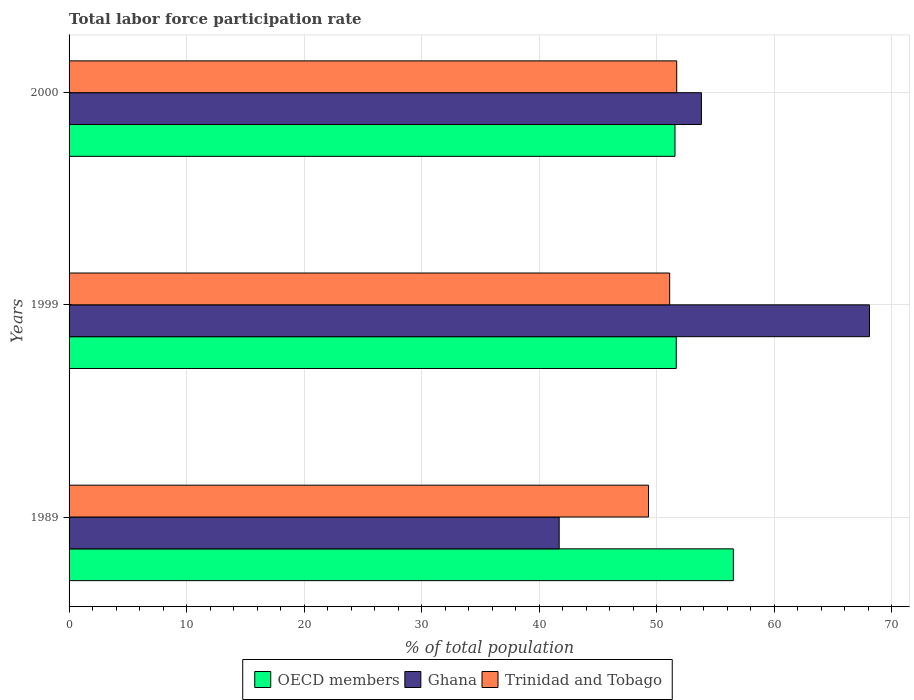How many different coloured bars are there?
Provide a succinct answer. 3. How many groups of bars are there?
Keep it short and to the point. 3. Are the number of bars on each tick of the Y-axis equal?
Offer a very short reply. Yes. How many bars are there on the 1st tick from the bottom?
Keep it short and to the point. 3. What is the total labor force participation rate in Trinidad and Tobago in 1999?
Offer a very short reply. 51.1. Across all years, what is the maximum total labor force participation rate in OECD members?
Offer a very short reply. 56.52. Across all years, what is the minimum total labor force participation rate in Trinidad and Tobago?
Your answer should be compact. 49.3. What is the total total labor force participation rate in Trinidad and Tobago in the graph?
Give a very brief answer. 152.1. What is the difference between the total labor force participation rate in Ghana in 1999 and that in 2000?
Make the answer very short. 14.3. What is the difference between the total labor force participation rate in OECD members in 1989 and the total labor force participation rate in Ghana in 1999?
Provide a short and direct response. -11.58. What is the average total labor force participation rate in Ghana per year?
Your answer should be compact. 54.53. In the year 1989, what is the difference between the total labor force participation rate in Ghana and total labor force participation rate in OECD members?
Your response must be concise. -14.82. What is the ratio of the total labor force participation rate in Trinidad and Tobago in 1989 to that in 2000?
Your answer should be very brief. 0.95. What is the difference between the highest and the second highest total labor force participation rate in Ghana?
Your answer should be compact. 14.3. What is the difference between the highest and the lowest total labor force participation rate in Trinidad and Tobago?
Your response must be concise. 2.4. In how many years, is the total labor force participation rate in Ghana greater than the average total labor force participation rate in Ghana taken over all years?
Offer a very short reply. 1. Is the sum of the total labor force participation rate in OECD members in 1989 and 2000 greater than the maximum total labor force participation rate in Trinidad and Tobago across all years?
Keep it short and to the point. Yes. How many bars are there?
Keep it short and to the point. 9. Are all the bars in the graph horizontal?
Give a very brief answer. Yes. How many legend labels are there?
Make the answer very short. 3. How are the legend labels stacked?
Keep it short and to the point. Horizontal. What is the title of the graph?
Make the answer very short. Total labor force participation rate. What is the label or title of the X-axis?
Give a very brief answer. % of total population. What is the % of total population of OECD members in 1989?
Provide a succinct answer. 56.52. What is the % of total population in Ghana in 1989?
Keep it short and to the point. 41.7. What is the % of total population of Trinidad and Tobago in 1989?
Keep it short and to the point. 49.3. What is the % of total population in OECD members in 1999?
Offer a very short reply. 51.66. What is the % of total population of Ghana in 1999?
Offer a very short reply. 68.1. What is the % of total population of Trinidad and Tobago in 1999?
Make the answer very short. 51.1. What is the % of total population of OECD members in 2000?
Make the answer very short. 51.55. What is the % of total population in Ghana in 2000?
Make the answer very short. 53.8. What is the % of total population in Trinidad and Tobago in 2000?
Offer a terse response. 51.7. Across all years, what is the maximum % of total population of OECD members?
Your answer should be compact. 56.52. Across all years, what is the maximum % of total population in Ghana?
Give a very brief answer. 68.1. Across all years, what is the maximum % of total population in Trinidad and Tobago?
Your response must be concise. 51.7. Across all years, what is the minimum % of total population of OECD members?
Your response must be concise. 51.55. Across all years, what is the minimum % of total population of Ghana?
Offer a very short reply. 41.7. Across all years, what is the minimum % of total population of Trinidad and Tobago?
Offer a very short reply. 49.3. What is the total % of total population of OECD members in the graph?
Offer a terse response. 159.73. What is the total % of total population in Ghana in the graph?
Give a very brief answer. 163.6. What is the total % of total population in Trinidad and Tobago in the graph?
Your response must be concise. 152.1. What is the difference between the % of total population in OECD members in 1989 and that in 1999?
Give a very brief answer. 4.86. What is the difference between the % of total population of Ghana in 1989 and that in 1999?
Offer a terse response. -26.4. What is the difference between the % of total population of Trinidad and Tobago in 1989 and that in 1999?
Your answer should be very brief. -1.8. What is the difference between the % of total population in OECD members in 1989 and that in 2000?
Your answer should be compact. 4.96. What is the difference between the % of total population in OECD members in 1999 and that in 2000?
Ensure brevity in your answer.  0.11. What is the difference between the % of total population in Ghana in 1999 and that in 2000?
Make the answer very short. 14.3. What is the difference between the % of total population in Trinidad and Tobago in 1999 and that in 2000?
Make the answer very short. -0.6. What is the difference between the % of total population in OECD members in 1989 and the % of total population in Ghana in 1999?
Your answer should be compact. -11.58. What is the difference between the % of total population of OECD members in 1989 and the % of total population of Trinidad and Tobago in 1999?
Your response must be concise. 5.42. What is the difference between the % of total population of Ghana in 1989 and the % of total population of Trinidad and Tobago in 1999?
Offer a terse response. -9.4. What is the difference between the % of total population in OECD members in 1989 and the % of total population in Ghana in 2000?
Give a very brief answer. 2.72. What is the difference between the % of total population in OECD members in 1989 and the % of total population in Trinidad and Tobago in 2000?
Ensure brevity in your answer.  4.82. What is the difference between the % of total population in OECD members in 1999 and the % of total population in Ghana in 2000?
Your answer should be compact. -2.14. What is the difference between the % of total population of OECD members in 1999 and the % of total population of Trinidad and Tobago in 2000?
Offer a very short reply. -0.04. What is the difference between the % of total population of Ghana in 1999 and the % of total population of Trinidad and Tobago in 2000?
Make the answer very short. 16.4. What is the average % of total population in OECD members per year?
Provide a short and direct response. 53.24. What is the average % of total population in Ghana per year?
Make the answer very short. 54.53. What is the average % of total population of Trinidad and Tobago per year?
Your response must be concise. 50.7. In the year 1989, what is the difference between the % of total population of OECD members and % of total population of Ghana?
Give a very brief answer. 14.82. In the year 1989, what is the difference between the % of total population of OECD members and % of total population of Trinidad and Tobago?
Provide a succinct answer. 7.22. In the year 1989, what is the difference between the % of total population of Ghana and % of total population of Trinidad and Tobago?
Ensure brevity in your answer.  -7.6. In the year 1999, what is the difference between the % of total population in OECD members and % of total population in Ghana?
Your answer should be compact. -16.44. In the year 1999, what is the difference between the % of total population of OECD members and % of total population of Trinidad and Tobago?
Ensure brevity in your answer.  0.56. In the year 2000, what is the difference between the % of total population of OECD members and % of total population of Ghana?
Make the answer very short. -2.25. In the year 2000, what is the difference between the % of total population in OECD members and % of total population in Trinidad and Tobago?
Offer a terse response. -0.15. What is the ratio of the % of total population of OECD members in 1989 to that in 1999?
Offer a very short reply. 1.09. What is the ratio of the % of total population in Ghana in 1989 to that in 1999?
Your response must be concise. 0.61. What is the ratio of the % of total population of Trinidad and Tobago in 1989 to that in 1999?
Provide a succinct answer. 0.96. What is the ratio of the % of total population in OECD members in 1989 to that in 2000?
Ensure brevity in your answer.  1.1. What is the ratio of the % of total population of Ghana in 1989 to that in 2000?
Ensure brevity in your answer.  0.78. What is the ratio of the % of total population of Trinidad and Tobago in 1989 to that in 2000?
Your response must be concise. 0.95. What is the ratio of the % of total population in Ghana in 1999 to that in 2000?
Ensure brevity in your answer.  1.27. What is the ratio of the % of total population of Trinidad and Tobago in 1999 to that in 2000?
Ensure brevity in your answer.  0.99. What is the difference between the highest and the second highest % of total population in OECD members?
Ensure brevity in your answer.  4.86. What is the difference between the highest and the second highest % of total population in Ghana?
Your answer should be very brief. 14.3. What is the difference between the highest and the second highest % of total population of Trinidad and Tobago?
Keep it short and to the point. 0.6. What is the difference between the highest and the lowest % of total population of OECD members?
Provide a short and direct response. 4.96. What is the difference between the highest and the lowest % of total population in Ghana?
Your answer should be compact. 26.4. 